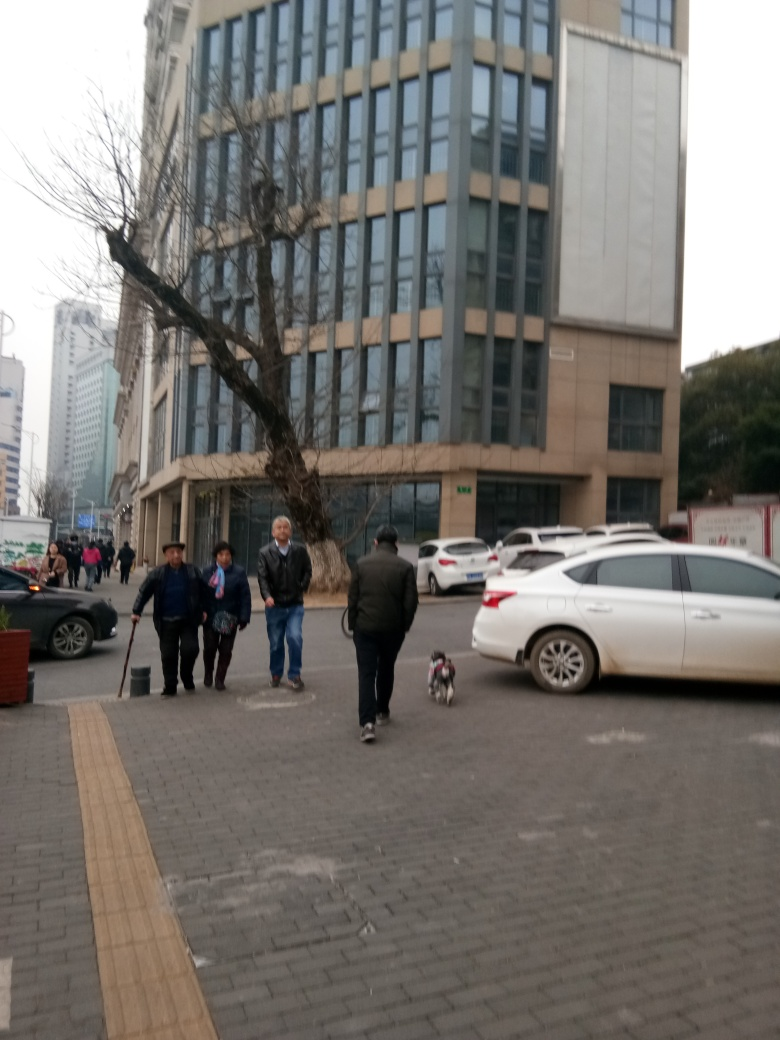Can you describe the weather that day? Given the overcast sky and the attire of the individuals, which includes jackets and long sleeves, it suggests a cool or mild climate, likely autumn or spring weather. 